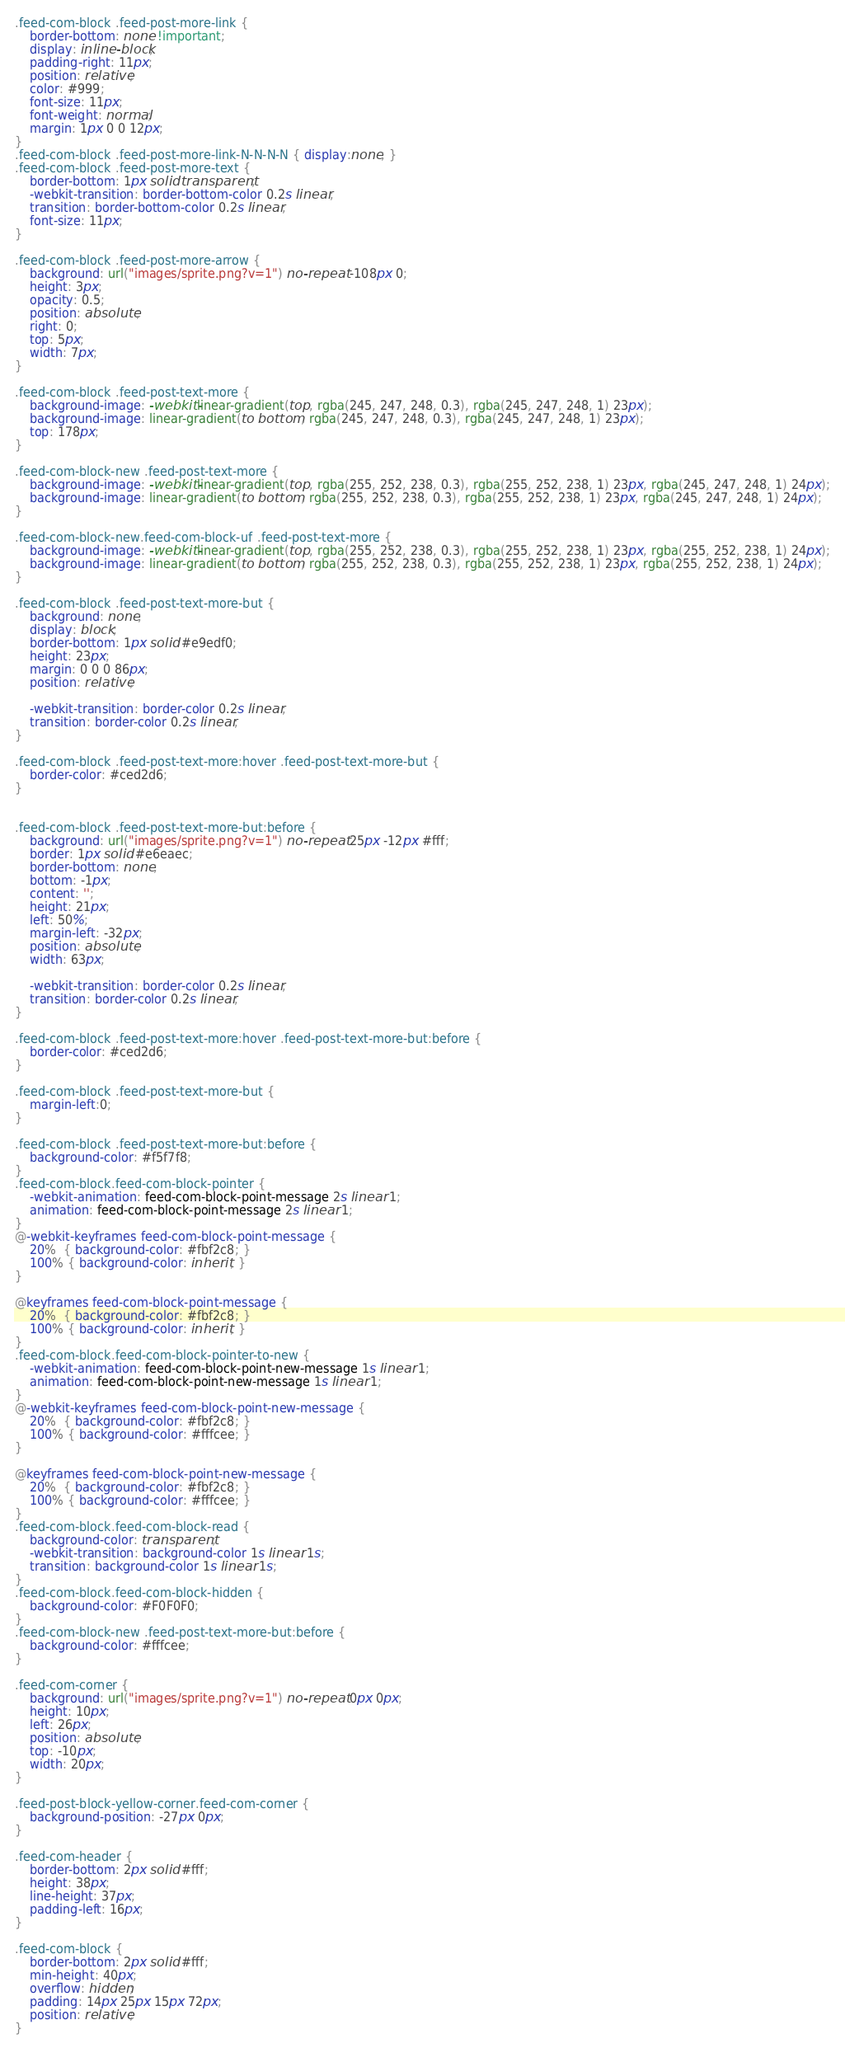Convert code to text. <code><loc_0><loc_0><loc_500><loc_500><_CSS_>.feed-com-block .feed-post-more-link {
	border-bottom: none !important;
	display: inline-block;
	padding-right: 11px;
	position: relative;
	color: #999;
	font-size: 11px;
	font-weight: normal;
	margin: 1px 0 0 12px;
}
.feed-com-block .feed-post-more-link-N-N-N-N { display:none; }
.feed-com-block .feed-post-more-text {
	border-bottom: 1px solid transparent;
	-webkit-transition: border-bottom-color 0.2s linear;
	transition: border-bottom-color 0.2s linear;
	font-size: 11px;
}

.feed-com-block .feed-post-more-arrow {
	background: url("images/sprite.png?v=1") no-repeat -108px 0;
	height: 3px;
	opacity: 0.5;
	position: absolute;
	right: 0;
	top: 5px;
	width: 7px;
}

.feed-com-block .feed-post-text-more {
	background-image: -webkit-linear-gradient(top, rgba(245, 247, 248, 0.3), rgba(245, 247, 248, 1) 23px);
	background-image: linear-gradient(to bottom, rgba(245, 247, 248, 0.3), rgba(245, 247, 248, 1) 23px);
	top: 178px;
}

.feed-com-block-new .feed-post-text-more {
	background-image: -webkit-linear-gradient(top, rgba(255, 252, 238, 0.3), rgba(255, 252, 238, 1) 23px, rgba(245, 247, 248, 1) 24px);
	background-image: linear-gradient(to bottom, rgba(255, 252, 238, 0.3), rgba(255, 252, 238, 1) 23px, rgba(245, 247, 248, 1) 24px);
}

.feed-com-block-new.feed-com-block-uf .feed-post-text-more {
	background-image: -webkit-linear-gradient(top, rgba(255, 252, 238, 0.3), rgba(255, 252, 238, 1) 23px, rgba(255, 252, 238, 1) 24px);
	background-image: linear-gradient(to bottom, rgba(255, 252, 238, 0.3), rgba(255, 252, 238, 1) 23px, rgba(255, 252, 238, 1) 24px);
}

.feed-com-block .feed-post-text-more-but {
	background: none;
	display: block;
	border-bottom: 1px solid #e9edf0;
	height: 23px;
	margin: 0 0 0 86px;
	position: relative;

	-webkit-transition: border-color 0.2s linear;
	transition: border-color 0.2s linear;
}

.feed-com-block .feed-post-text-more:hover .feed-post-text-more-but {
	border-color: #ced2d6;
}


.feed-com-block .feed-post-text-more-but:before {
	background: url("images/sprite.png?v=1") no-repeat 25px -12px #fff;
	border: 1px solid #e6eaec;
	border-bottom: none;
	bottom: -1px;
	content: '';
	height: 21px;
	left: 50%;
	margin-left: -32px;
	position: absolute;
	width: 63px;

	-webkit-transition: border-color 0.2s linear;
	transition: border-color 0.2s linear;
}

.feed-com-block .feed-post-text-more:hover .feed-post-text-more-but:before {
	border-color: #ced2d6;
}

.feed-com-block .feed-post-text-more-but {
	margin-left:0;
}

.feed-com-block .feed-post-text-more-but:before {
	background-color: #f5f7f8;
}
.feed-com-block.feed-com-block-pointer {
	-webkit-animation: feed-com-block-point-message 2s linear 1;
	animation: feed-com-block-point-message 2s linear 1;
}
@-webkit-keyframes feed-com-block-point-message {
	20%  { background-color: #fbf2c8; }
	100% { background-color: inherit; }
}

@keyframes feed-com-block-point-message {
	20%  { background-color: #fbf2c8; }
	100% { background-color: inherit; }
}
.feed-com-block.feed-com-block-pointer-to-new {
	-webkit-animation: feed-com-block-point-new-message 1s linear 1;
	animation: feed-com-block-point-new-message 1s linear 1;
}
@-webkit-keyframes feed-com-block-point-new-message {
	20%  { background-color: #fbf2c8; }
	100% { background-color: #fffcee; }
}

@keyframes feed-com-block-point-new-message {
	20%  { background-color: #fbf2c8; }
	100% { background-color: #fffcee; }
}
.feed-com-block.feed-com-block-read {
	background-color: transparent;
	-webkit-transition: background-color 1s linear 1s;
	transition: background-color 1s linear 1s;
}
.feed-com-block.feed-com-block-hidden {
	background-color: #F0F0F0;
}
.feed-com-block-new .feed-post-text-more-but:before {
	background-color: #fffcee;
}

.feed-com-corner {
	background: url("images/sprite.png?v=1") no-repeat 0px 0px;
	height: 10px;
	left: 26px;
	position: absolute;
	top: -10px;
	width: 20px;
}

.feed-post-block-yellow-corner.feed-com-corner {
	background-position: -27px 0px;
}

.feed-com-header {
	border-bottom: 2px solid #fff;
	height: 38px;
	line-height: 37px;
	padding-left: 16px;
}

.feed-com-block {
	border-bottom: 2px solid #fff;
	min-height: 40px;
	overflow: hidden;
	padding: 14px 25px 15px 72px;
	position: relative;
}
</code> 